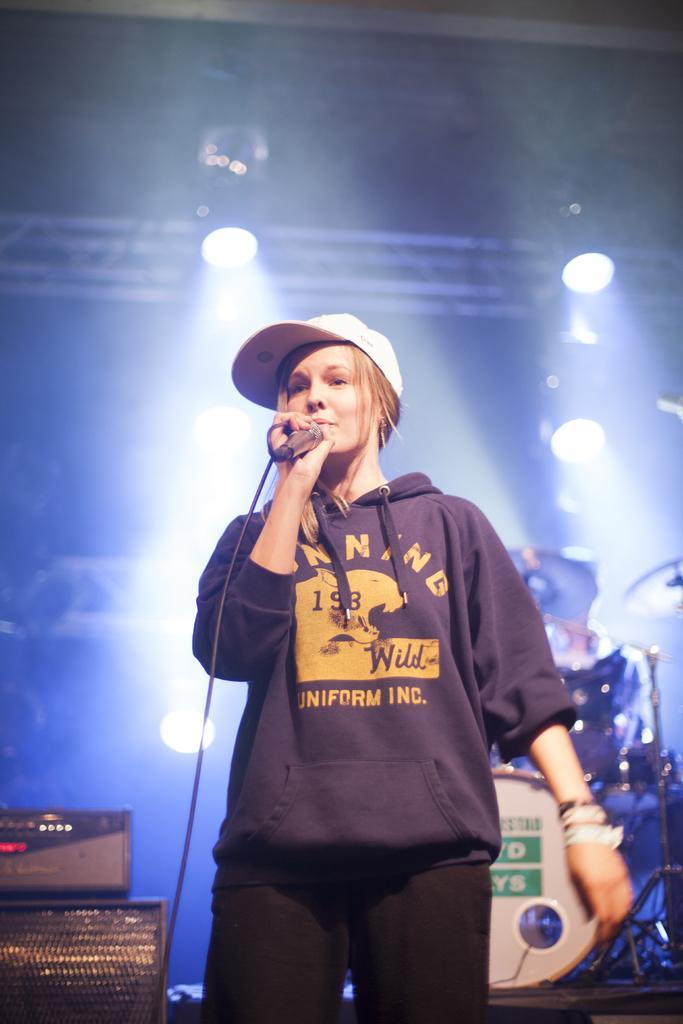Can you describe this image briefly? In this picture we can see a woman wore a cap and holding a mic with her hand and standing and in the background we can see drums, lights, speakers. 